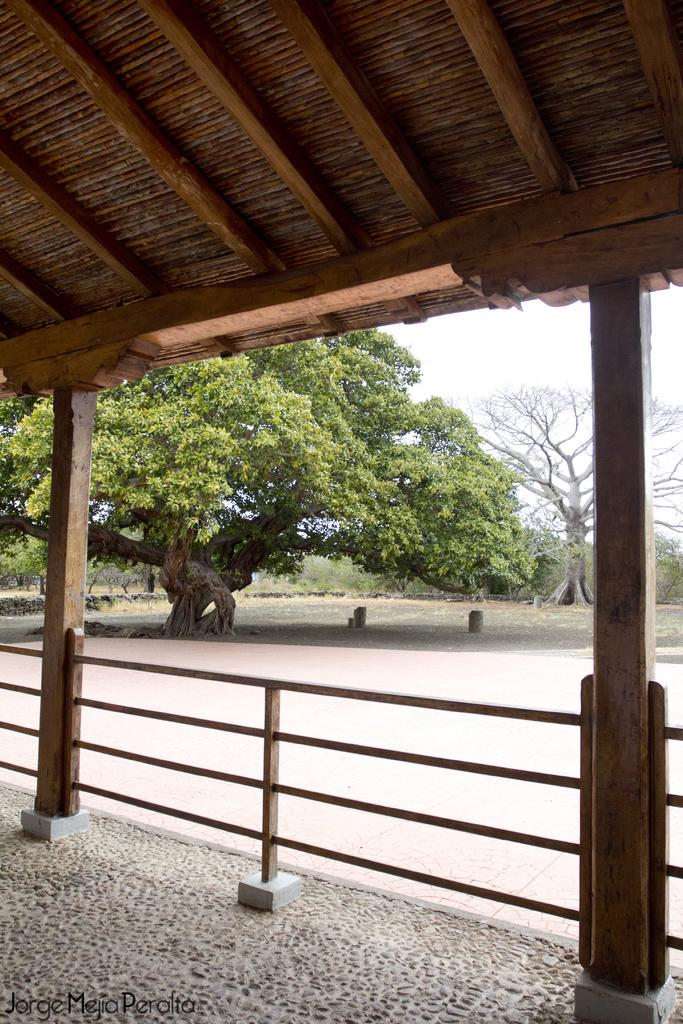What type of roof is visible in the image? There is a wooden roof top in the image. Are there any structural elements supporting the roof? Yes, the roof top has supporting poles. What else can be seen in the middle of the image? There are trees in the middle of the image. What type of paste is being used to drive the event in the image? There is no paste, driving, or event present in the image. 